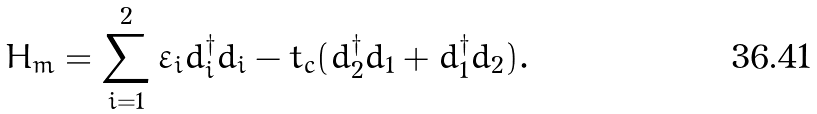<formula> <loc_0><loc_0><loc_500><loc_500>H _ { m } = \sum _ { i = 1 } ^ { 2 } \varepsilon _ { i } d _ { i } ^ { \dag } d _ { i } - t _ { c } ( d _ { 2 } ^ { \dag } d _ { 1 } + d _ { 1 } ^ { \dag } d _ { 2 } ) .</formula> 